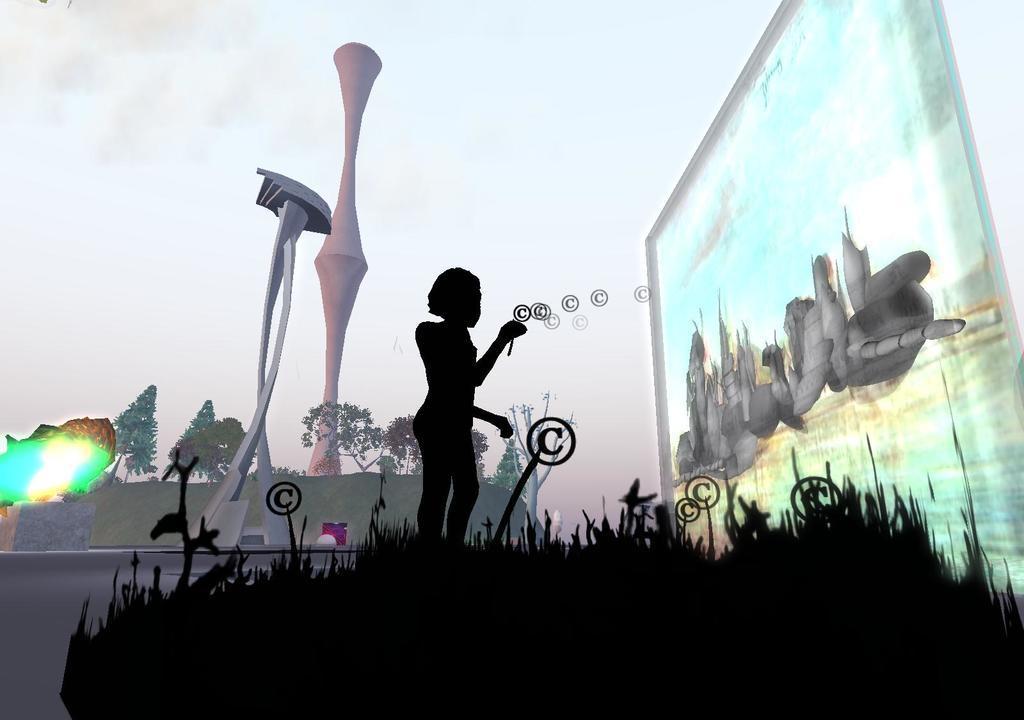In one or two sentences, can you explain what this image depicts? It is the graphical image in which there is a person in the middle. On the right side there is a board on which there is some painting. At the bottom there are plants which are in black color. In the background there are trees. In the middle there is a pole and some art. On the left side there is a light. 